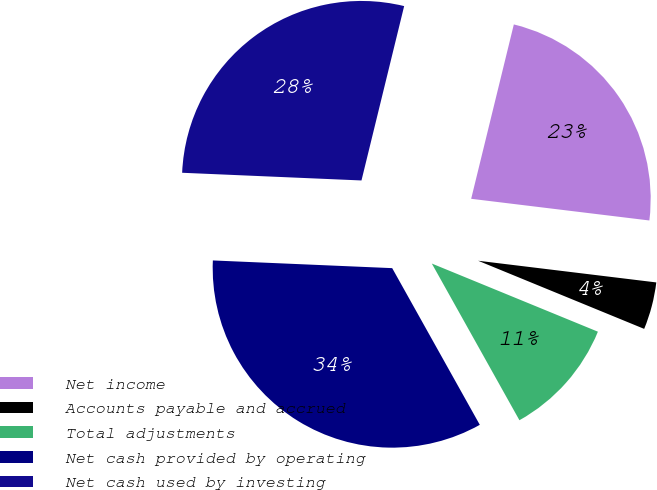Convert chart. <chart><loc_0><loc_0><loc_500><loc_500><pie_chart><fcel>Net income<fcel>Accounts payable and accrued<fcel>Total adjustments<fcel>Net cash provided by operating<fcel>Net cash used by investing<nl><fcel>23.11%<fcel>4.27%<fcel>10.69%<fcel>33.8%<fcel>28.14%<nl></chart> 